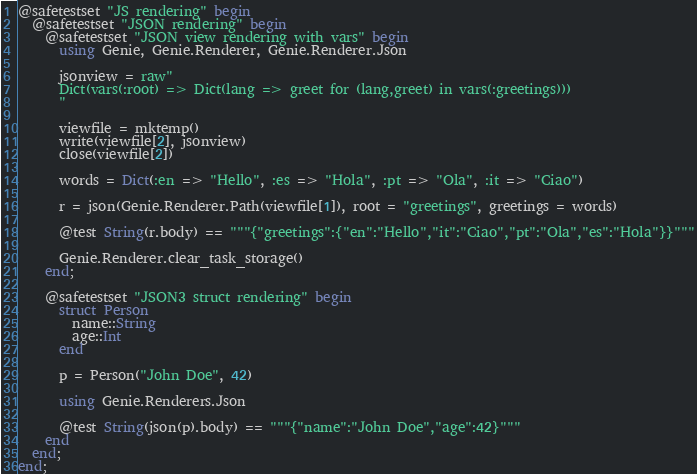<code> <loc_0><loc_0><loc_500><loc_500><_Julia_>@safetestset "JS rendering" begin
  @safetestset "JSON rendering" begin
    @safetestset "JSON view rendering with vars" begin
      using Genie, Genie.Renderer, Genie.Renderer.Json

      jsonview = raw"
      Dict(vars(:root) => Dict(lang => greet for (lang,greet) in vars(:greetings)))
      "

      viewfile = mktemp()
      write(viewfile[2], jsonview)
      close(viewfile[2])

      words = Dict(:en => "Hello", :es => "Hola", :pt => "Ola", :it => "Ciao")

      r = json(Genie.Renderer.Path(viewfile[1]), root = "greetings", greetings = words)

      @test String(r.body) == """{"greetings":{"en":"Hello","it":"Ciao","pt":"Ola","es":"Hola"}}"""

      Genie.Renderer.clear_task_storage()
    end;

    @safetestset "JSON3 struct rendering" begin
      struct Person
        name::String
        age::Int
      end

      p = Person("John Doe", 42)

      using Genie.Renderers.Json

      @test String(json(p).body) == """{"name":"John Doe","age":42}"""
    end
  end;
end;</code> 